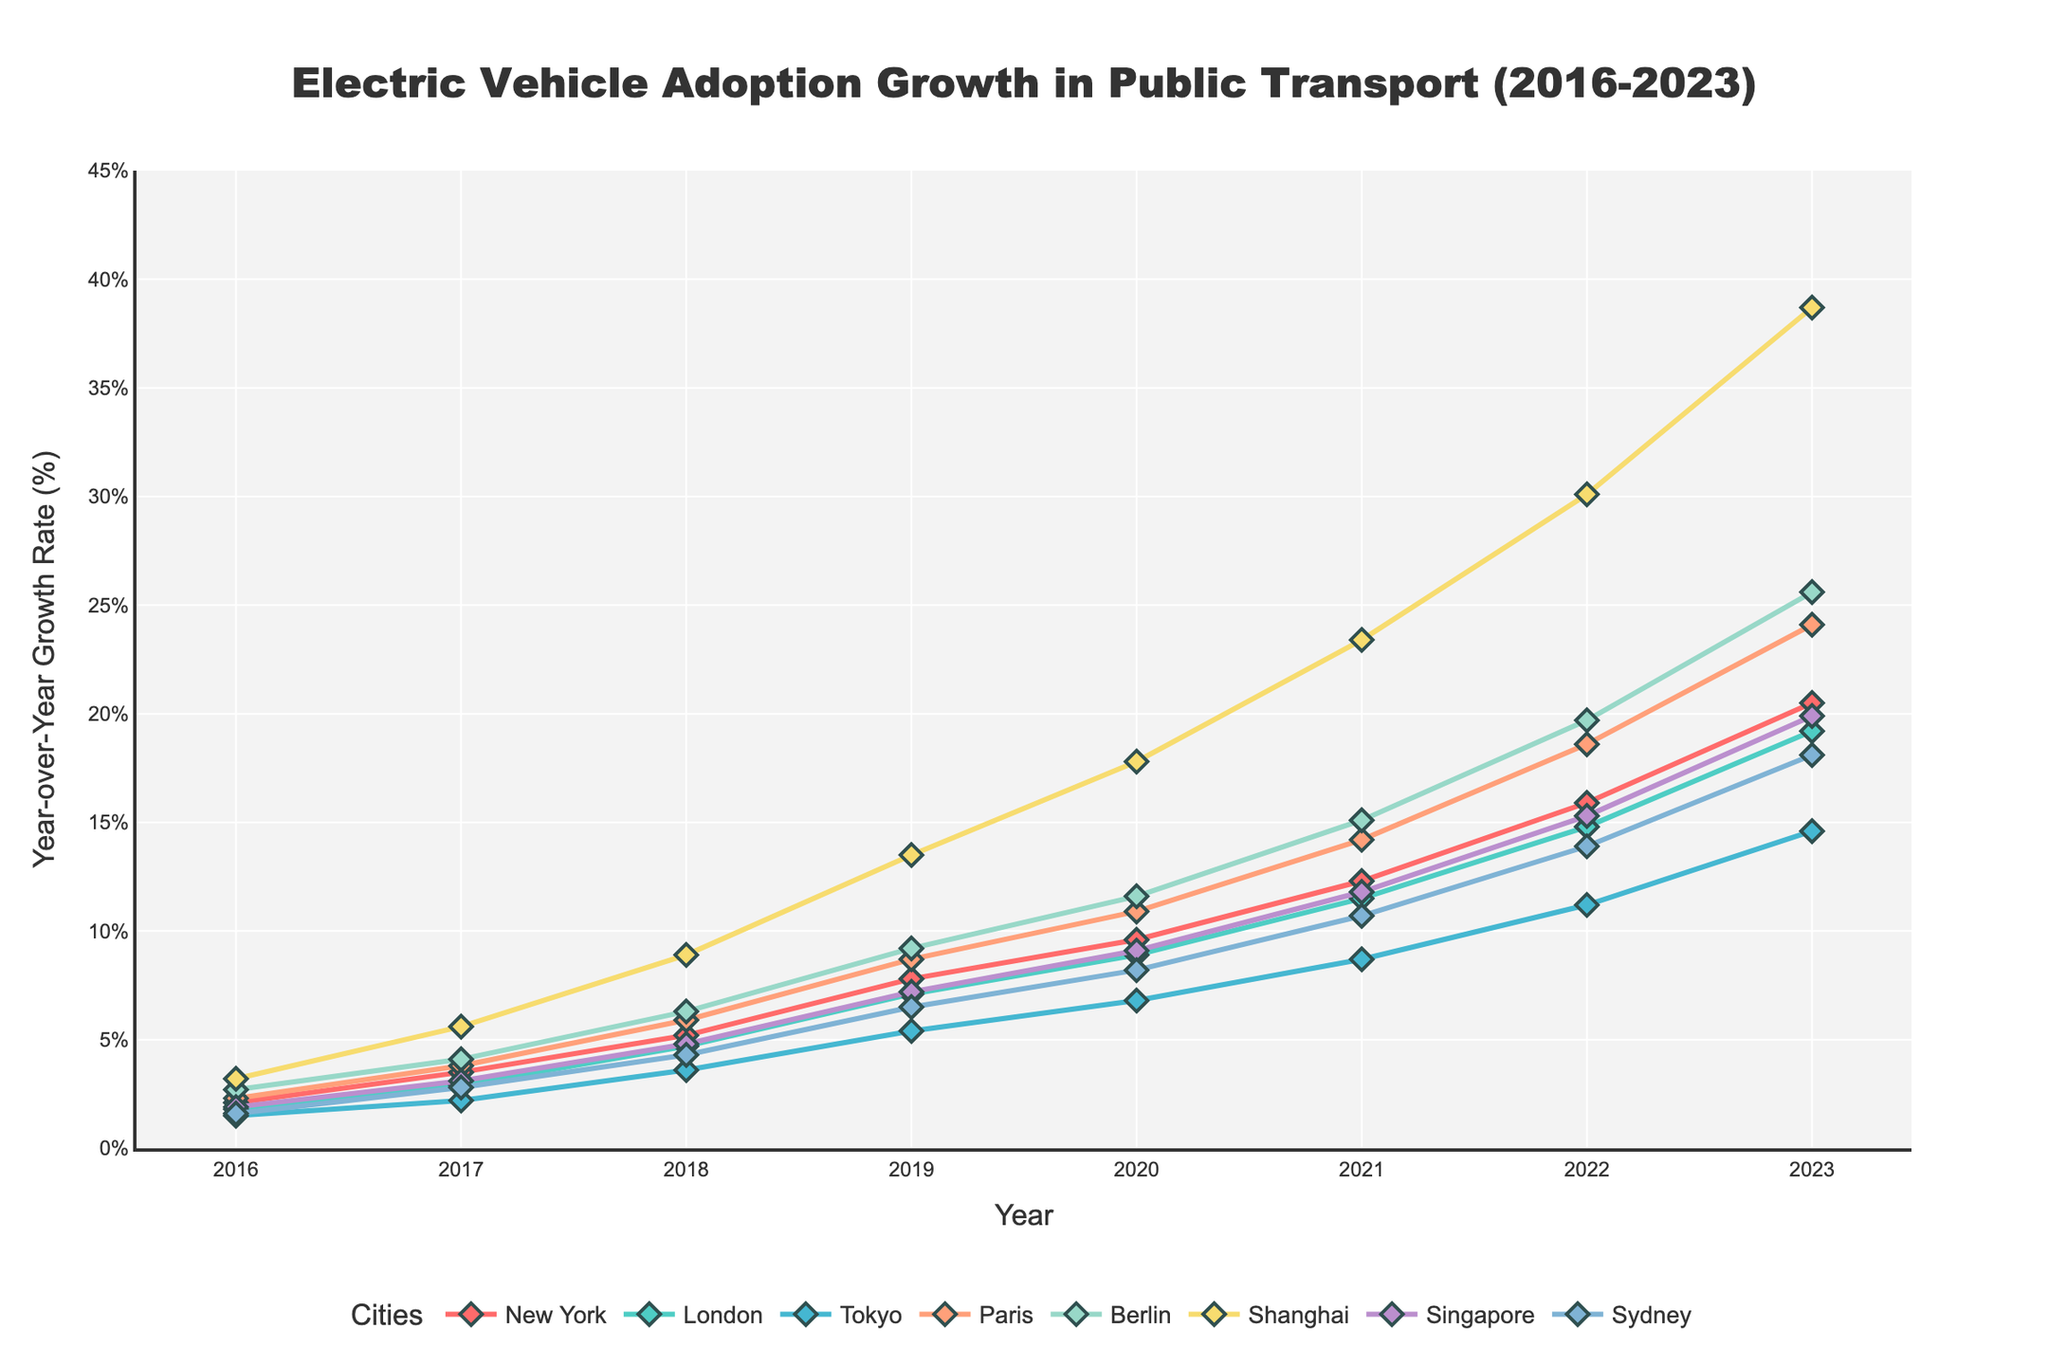Which city shows the highest year-over-year growth rate in electric vehicle adoption for 2023? The chart details each city's growth rate for each year. For 2023, Shanghai has the highest growth rate.
Answer: Shanghai Which city had the lowest year-over-year growth rate in 2020? By observing the growth rates for 2020, Tokyo had the lowest growth rate among the listed cities.
Answer: Tokyo What is the average year-over-year growth rate for New York from 2016 to 2023? Sum the year-over-year growth rates for New York from 2016 to 2023: (2.1 + 3.5 + 5.2 + 7.8 + 9.6 + 12.3 + 15.9 + 20.5) = 76.9. Then, divide by the number of years (8): 76.9 / 8 = 9.61.
Answer: 9.61 Compare the year-over-year growth rates of London and Paris in 2018. Which city had a higher growth rate? In 2018, London's growth rate was 4.7%, while Paris's growth rate was 5.9%. Therefore, Paris had a higher growth rate.
Answer: Paris Which city had the most significant increase in growth rate between 2019 and 2020? Calculate the difference between 2019 and 2020 for each city and identify the largest difference. Shanghai had an increase from 13.5% to 17.8%, which is a 4.3% increase, the highest among all cities.
Answer: Shanghai In 2023, which city's growth rate in electric vehicle adoption was closest to 20%? From the chart, New York's growth rate was 20.5% in 2023, which is closest to 20%.
Answer: New York How did Berlin's year-over-year growth rate in 2023 compare to its rate in 2019? Berlin's growth rate in 2019 was 9.2%, and in 2023 it was 25.6%. This shows a significant increase in Berlin's growth rate.
Answer: Increased significantly What is the total combined growth rate for all cities in 2017? To find the combined growth rate, sum the growth rates of all cities in 2017: 3.5 + 2.9 + 2.2 + 3.8 + 4.1 + 5.6 + 3.1 + 2.8 = 28.0%.
Answer: 28.0 Did any city have a negative growth rate during these years? By observing the entire chart, no cities show a negative growth rate; all rates are positive.
Answer: No What is the trend in the year-over-year growth rate for Tokyo from 2016 to 2023? Tokyo’s growth rate increased consistently from 1.5% in 2016 to 14.6% in 2023, indicating a positive upward trend.
Answer: Positive upward trend 